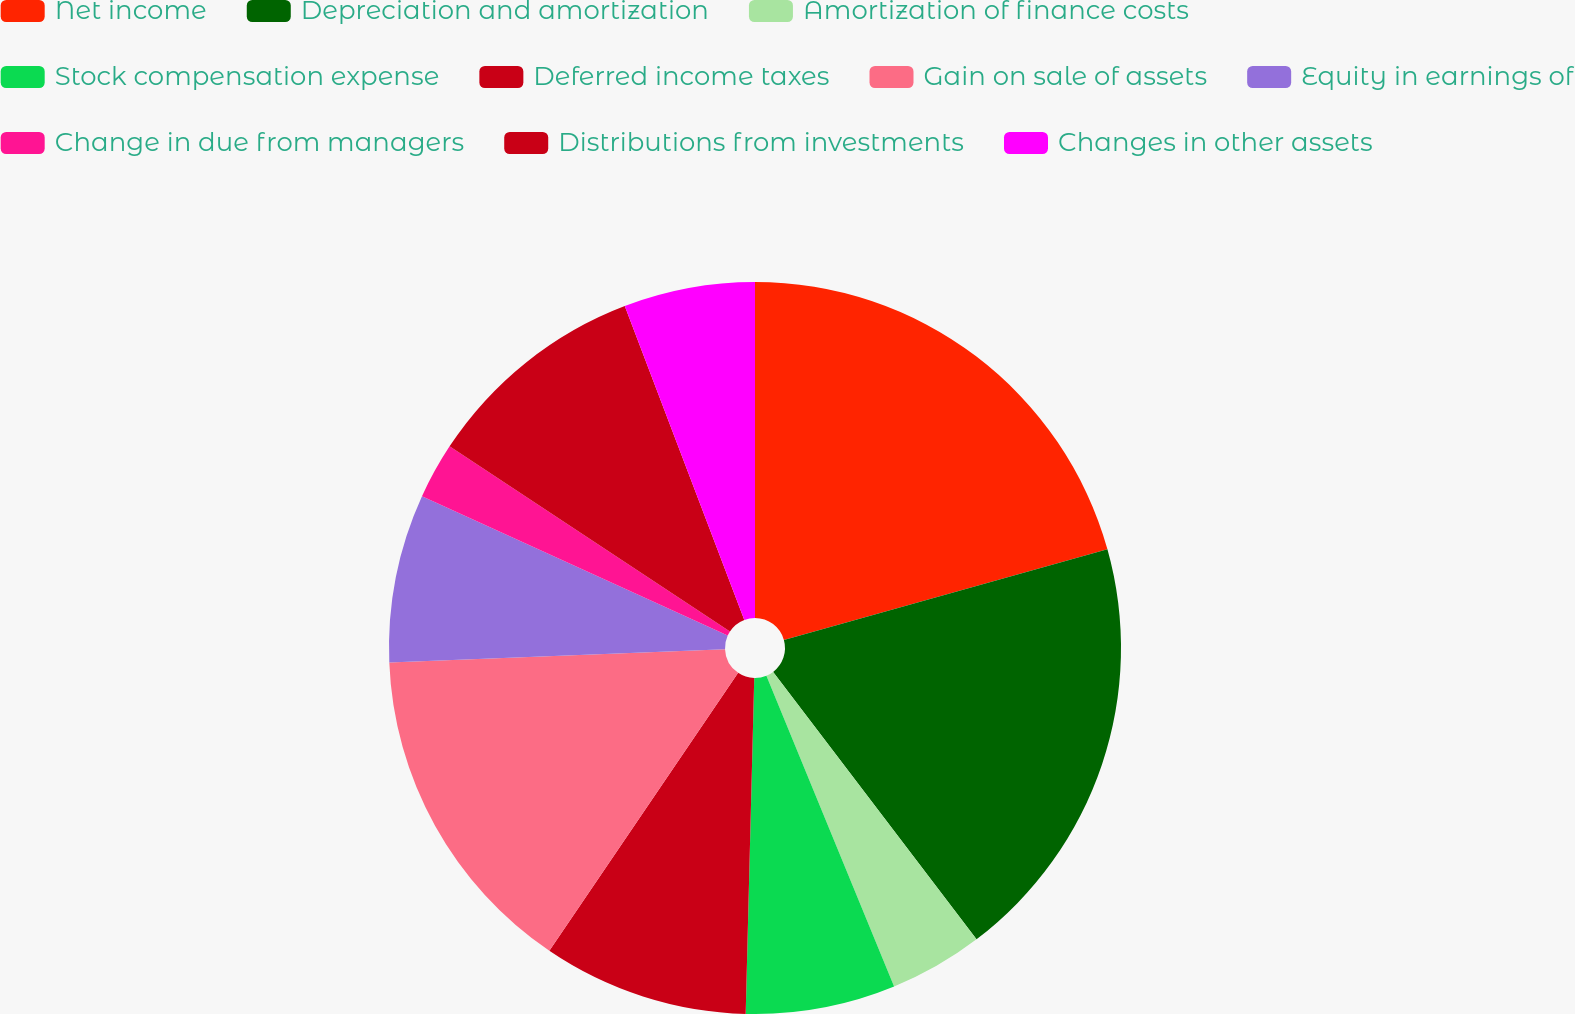Convert chart to OTSL. <chart><loc_0><loc_0><loc_500><loc_500><pie_chart><fcel>Net income<fcel>Depreciation and amortization<fcel>Amortization of finance costs<fcel>Stock compensation expense<fcel>Deferred income taxes<fcel>Gain on sale of assets<fcel>Equity in earnings of<fcel>Change in due from managers<fcel>Distributions from investments<fcel>Changes in other assets<nl><fcel>20.65%<fcel>19.0%<fcel>4.14%<fcel>6.61%<fcel>9.09%<fcel>14.87%<fcel>7.44%<fcel>2.48%<fcel>9.92%<fcel>5.79%<nl></chart> 